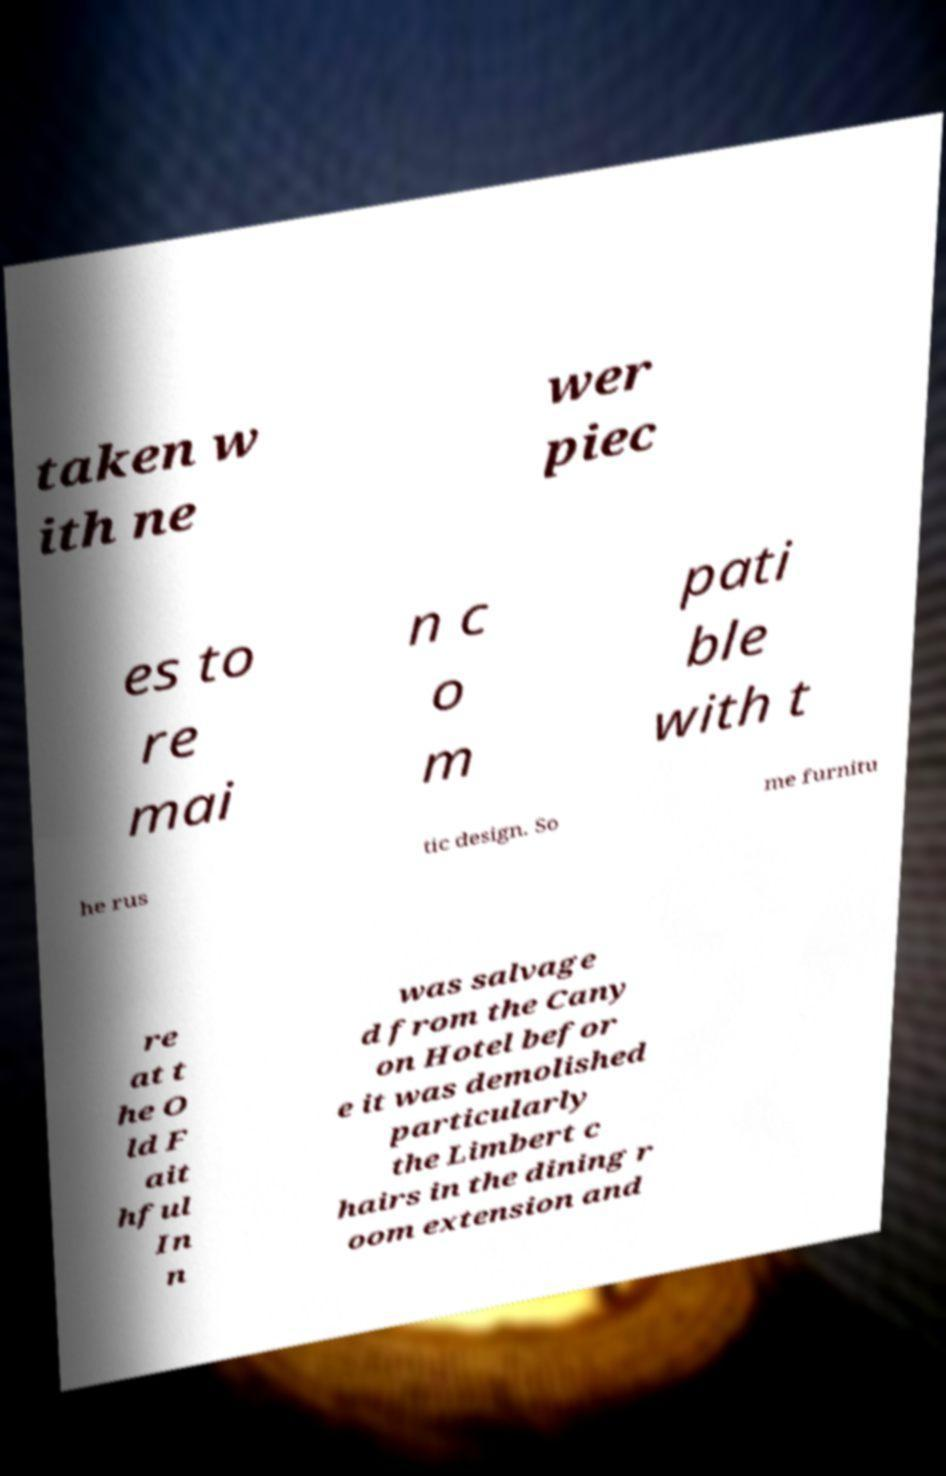For documentation purposes, I need the text within this image transcribed. Could you provide that? taken w ith ne wer piec es to re mai n c o m pati ble with t he rus tic design. So me furnitu re at t he O ld F ait hful In n was salvage d from the Cany on Hotel befor e it was demolished particularly the Limbert c hairs in the dining r oom extension and 